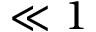Convert formula to latex. <formula><loc_0><loc_0><loc_500><loc_500>{ \ll 1 }</formula> 